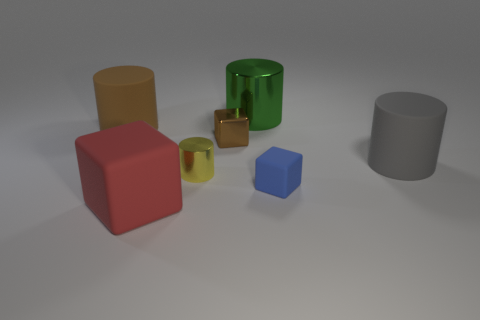What is the shape of the gray rubber thing?
Your response must be concise. Cylinder. Is the large metal object the same color as the large matte block?
Provide a succinct answer. No. What number of objects are cylinders on the right side of the brown rubber object or purple shiny spheres?
Give a very brief answer. 3. There is a yellow thing that is the same material as the tiny brown cube; what is its size?
Your answer should be compact. Small. Are there more big green shiny cylinders that are behind the gray cylinder than big purple matte cylinders?
Your answer should be very brief. Yes. Does the small yellow object have the same shape as the big object that is behind the big brown rubber object?
Offer a very short reply. Yes. What number of large things are either brown rubber cylinders or cylinders?
Make the answer very short. 3. The thing that is the same color as the metallic cube is what size?
Your response must be concise. Large. The large cylinder behind the cylinder that is on the left side of the large red rubber block is what color?
Ensure brevity in your answer.  Green. Is the large gray cylinder made of the same material as the small cube left of the green cylinder?
Ensure brevity in your answer.  No. 